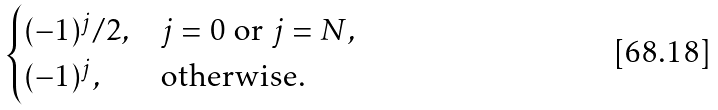<formula> <loc_0><loc_0><loc_500><loc_500>\begin{cases} ( - 1 ) ^ { j } / 2 , & j = 0 \text { or } j = N , \\ ( - 1 ) ^ { j } , & \text {otherwise.} \end{cases}</formula> 